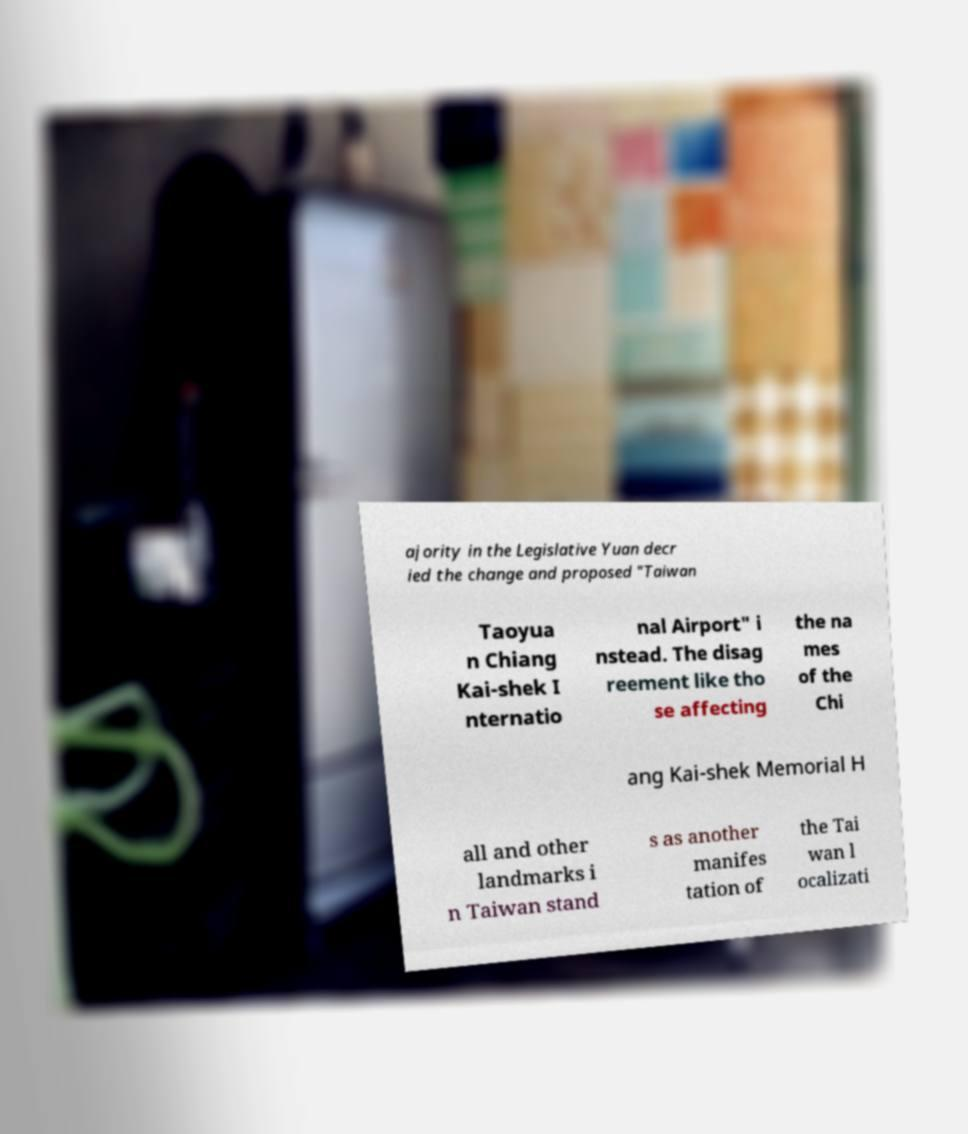I need the written content from this picture converted into text. Can you do that? ajority in the Legislative Yuan decr ied the change and proposed "Taiwan Taoyua n Chiang Kai-shek I nternatio nal Airport" i nstead. The disag reement like tho se affecting the na mes of the Chi ang Kai-shek Memorial H all and other landmarks i n Taiwan stand s as another manifes tation of the Tai wan l ocalizati 